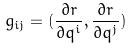<formula> <loc_0><loc_0><loc_500><loc_500>g _ { i j } = ( \frac { \partial r } { \partial q ^ { i } } , \frac { \partial r } { \partial q ^ { j } } )</formula> 